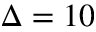Convert formula to latex. <formula><loc_0><loc_0><loc_500><loc_500>\Delta = 1 0</formula> 